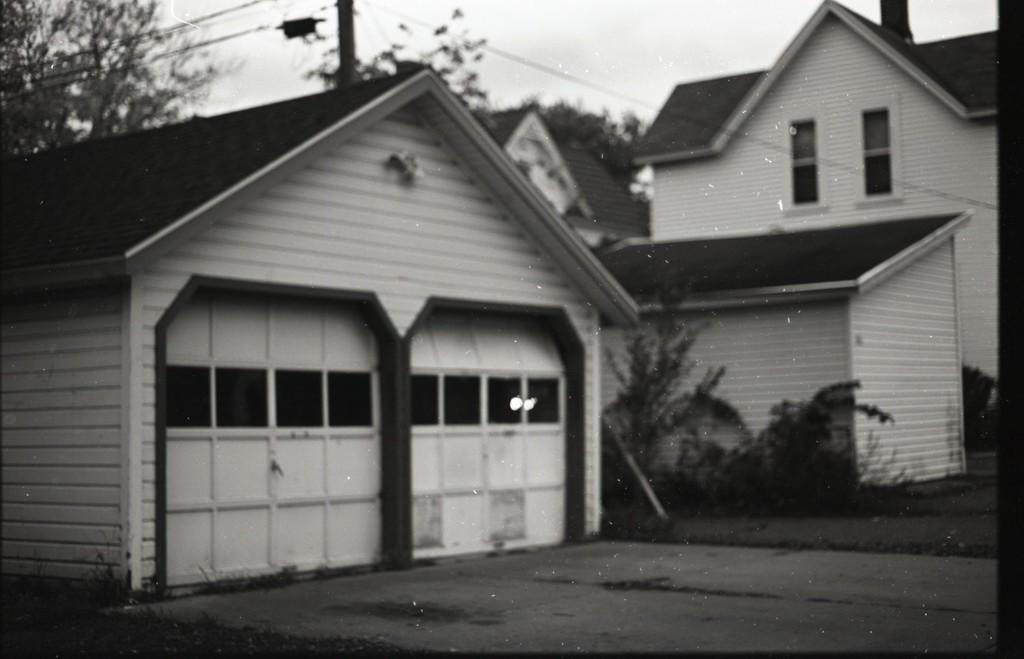What is the main structure in the image? There is a building in the image. What can be seen in the background of the image? There are trees in the background of the image. How is the sky depicted in the image? The sky is visible in the image, and it is described as white in color. What type of jewel is hanging from the branches of the trees in the image? There are no jewels present in the image; the trees are in the background, and the main focus is on the building and the white sky. 